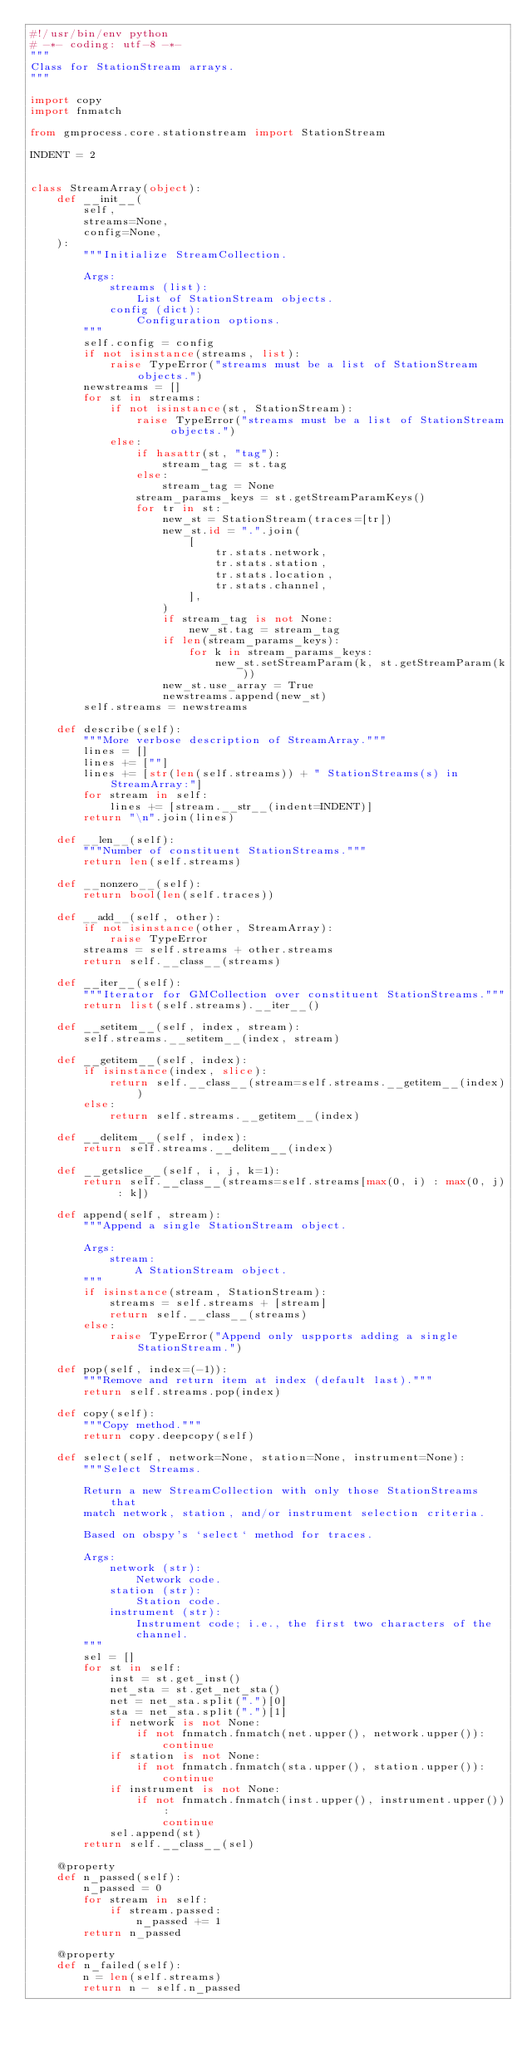<code> <loc_0><loc_0><loc_500><loc_500><_Python_>#!/usr/bin/env python
# -*- coding: utf-8 -*-
"""
Class for StationStream arrays.
"""

import copy
import fnmatch

from gmprocess.core.stationstream import StationStream

INDENT = 2


class StreamArray(object):
    def __init__(
        self,
        streams=None,
        config=None,
    ):
        """Initialize StreamCollection.

        Args:
            streams (list):
                List of StationStream objects.
            config (dict):
                Configuration options.
        """
        self.config = config
        if not isinstance(streams, list):
            raise TypeError("streams must be a list of StationStream objects.")
        newstreams = []
        for st in streams:
            if not isinstance(st, StationStream):
                raise TypeError("streams must be a list of StationStream objects.")
            else:
                if hasattr(st, "tag"):
                    stream_tag = st.tag
                else:
                    stream_tag = None
                stream_params_keys = st.getStreamParamKeys()
                for tr in st:
                    new_st = StationStream(traces=[tr])
                    new_st.id = ".".join(
                        [
                            tr.stats.network,
                            tr.stats.station,
                            tr.stats.location,
                            tr.stats.channel,
                        ],
                    )
                    if stream_tag is not None:
                        new_st.tag = stream_tag
                    if len(stream_params_keys):
                        for k in stream_params_keys:
                            new_st.setStreamParam(k, st.getStreamParam(k))
                    new_st.use_array = True
                    newstreams.append(new_st)
        self.streams = newstreams

    def describe(self):
        """More verbose description of StreamArray."""
        lines = []
        lines += [""]
        lines += [str(len(self.streams)) + " StationStreams(s) in StreamArray:"]
        for stream in self:
            lines += [stream.__str__(indent=INDENT)]
        return "\n".join(lines)

    def __len__(self):
        """Number of constituent StationStreams."""
        return len(self.streams)

    def __nonzero__(self):
        return bool(len(self.traces))

    def __add__(self, other):
        if not isinstance(other, StreamArray):
            raise TypeError
        streams = self.streams + other.streams
        return self.__class__(streams)

    def __iter__(self):
        """Iterator for GMCollection over constituent StationStreams."""
        return list(self.streams).__iter__()

    def __setitem__(self, index, stream):
        self.streams.__setitem__(index, stream)

    def __getitem__(self, index):
        if isinstance(index, slice):
            return self.__class__(stream=self.streams.__getitem__(index))
        else:
            return self.streams.__getitem__(index)

    def __delitem__(self, index):
        return self.streams.__delitem__(index)

    def __getslice__(self, i, j, k=1):
        return self.__class__(streams=self.streams[max(0, i) : max(0, j) : k])

    def append(self, stream):
        """Append a single StationStream object.

        Args:
            stream:
                A StationStream object.
        """
        if isinstance(stream, StationStream):
            streams = self.streams + [stream]
            return self.__class__(streams)
        else:
            raise TypeError("Append only uspports adding a single StationStream.")

    def pop(self, index=(-1)):
        """Remove and return item at index (default last)."""
        return self.streams.pop(index)

    def copy(self):
        """Copy method."""
        return copy.deepcopy(self)

    def select(self, network=None, station=None, instrument=None):
        """Select Streams.

        Return a new StreamCollection with only those StationStreams that
        match network, station, and/or instrument selection criteria.

        Based on obspy's `select` method for traces.

        Args:
            network (str):
                Network code.
            station (str):
                Station code.
            instrument (str):
                Instrument code; i.e., the first two characters of the
                channel.
        """
        sel = []
        for st in self:
            inst = st.get_inst()
            net_sta = st.get_net_sta()
            net = net_sta.split(".")[0]
            sta = net_sta.split(".")[1]
            if network is not None:
                if not fnmatch.fnmatch(net.upper(), network.upper()):
                    continue
            if station is not None:
                if not fnmatch.fnmatch(sta.upper(), station.upper()):
                    continue
            if instrument is not None:
                if not fnmatch.fnmatch(inst.upper(), instrument.upper()):
                    continue
            sel.append(st)
        return self.__class__(sel)

    @property
    def n_passed(self):
        n_passed = 0
        for stream in self:
            if stream.passed:
                n_passed += 1
        return n_passed

    @property
    def n_failed(self):
        n = len(self.streams)
        return n - self.n_passed
</code> 